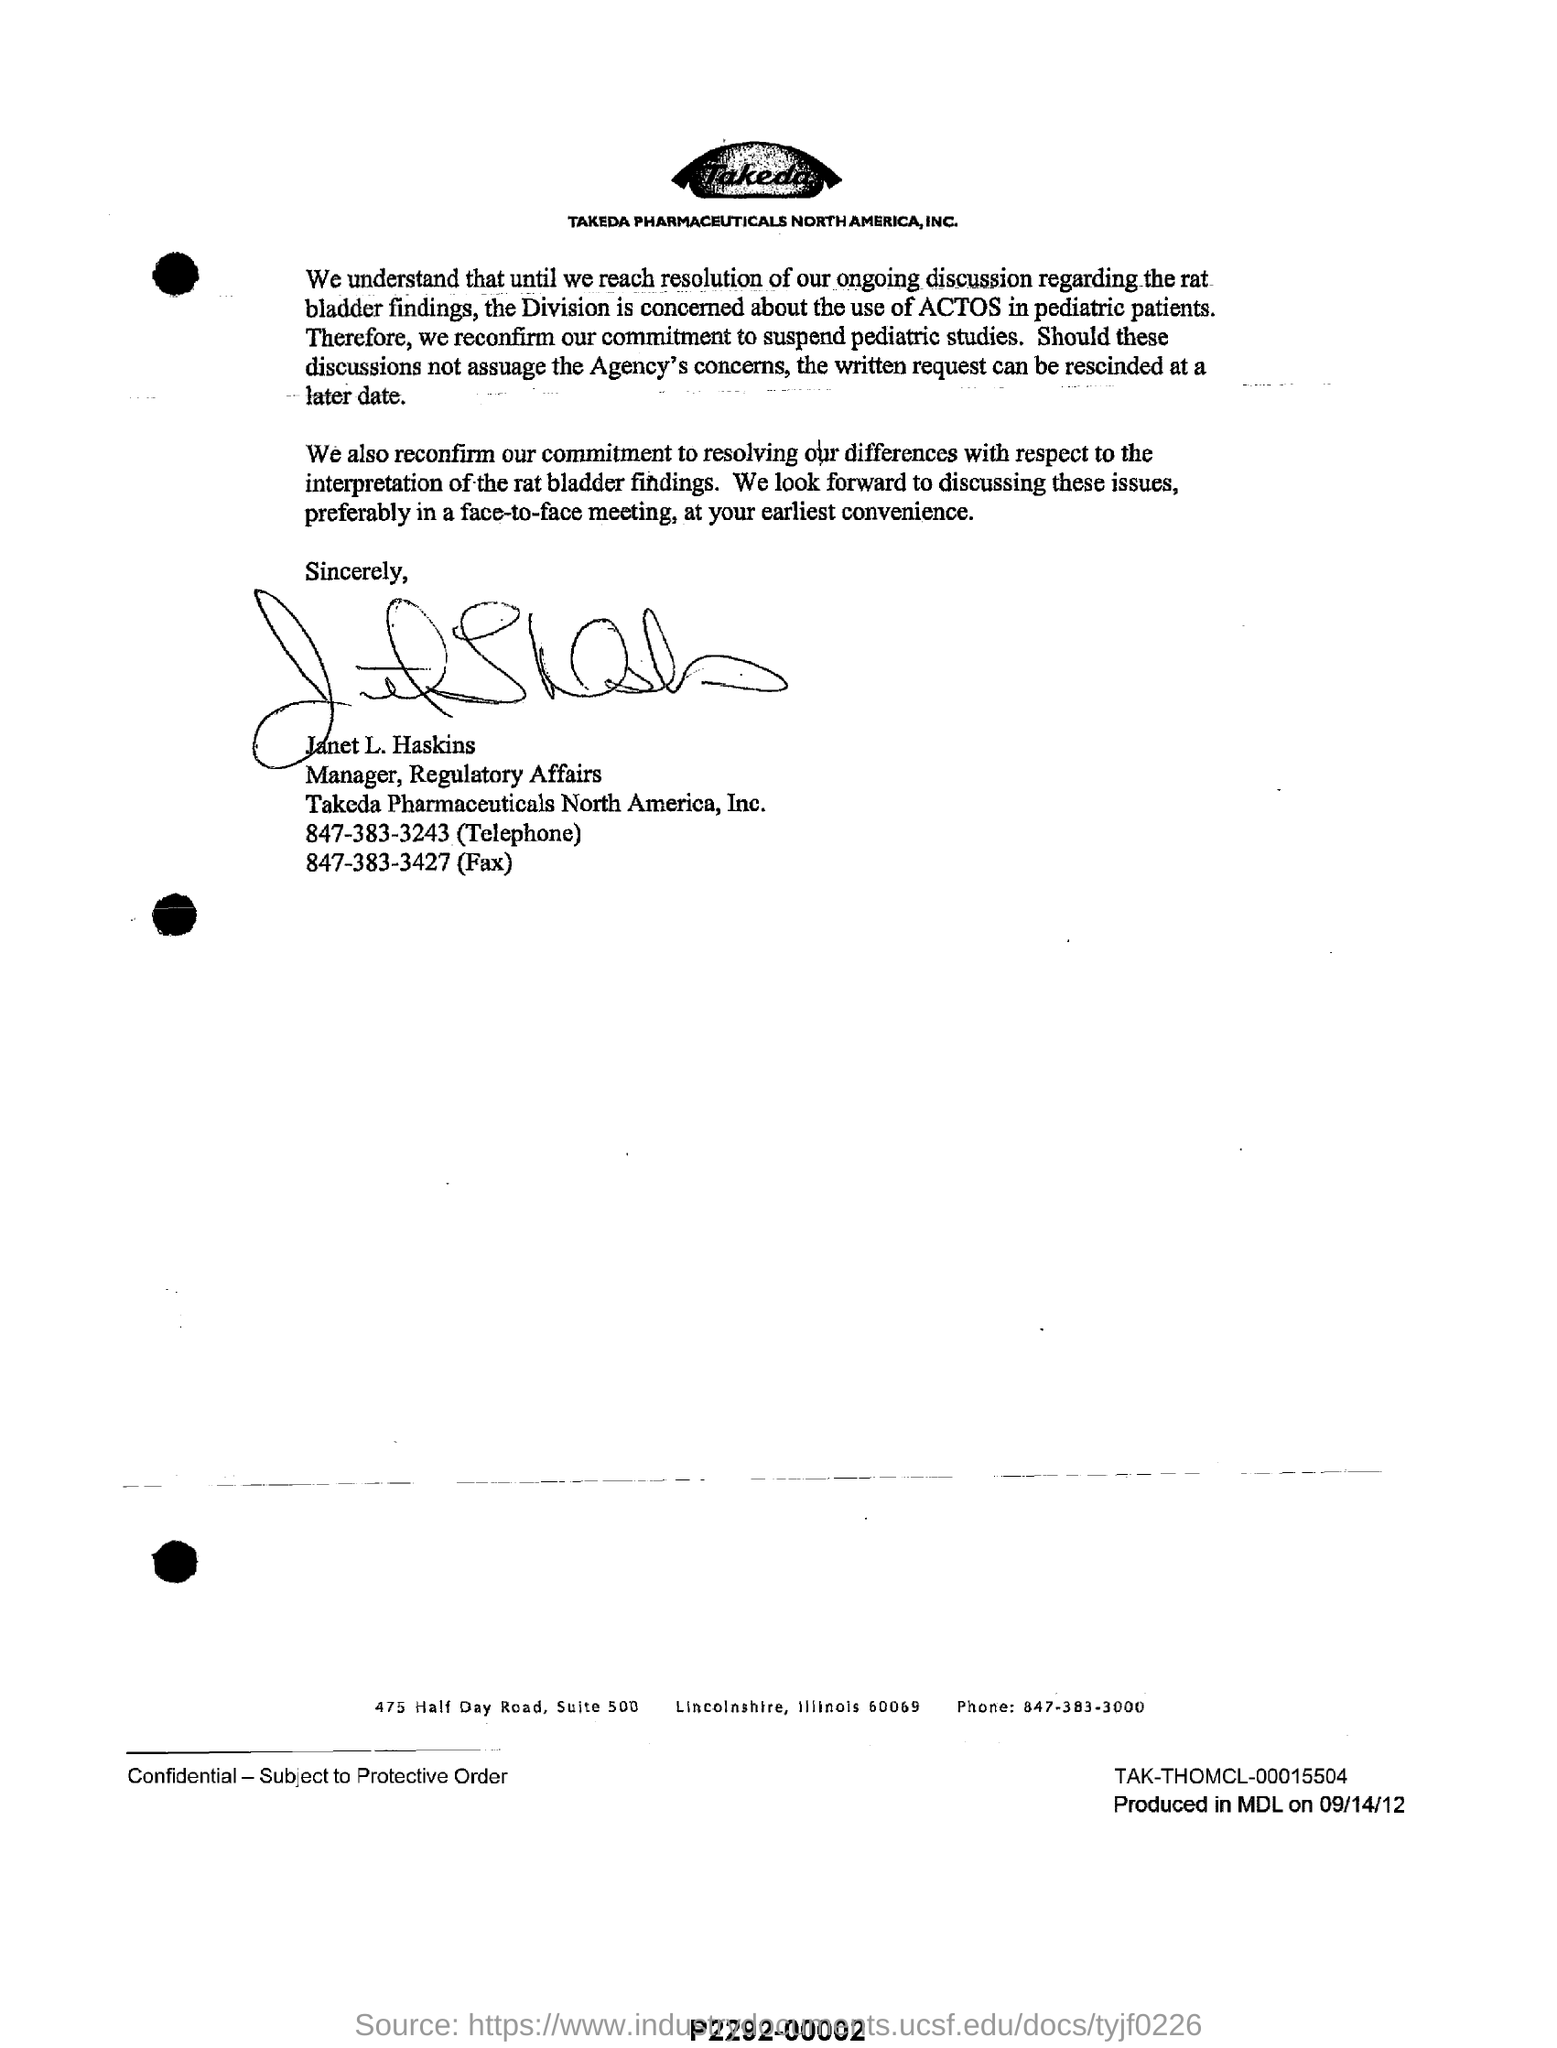Highlight a few significant elements in this photo. The document mentions TAKEDA PHARMACEUTICALS NORTH AMERICA, INC. as a pharmaceutical company. The image contains the text 'Takeda'. The fax number of Takeda Pharmaceuticals is 847-383-3427. 